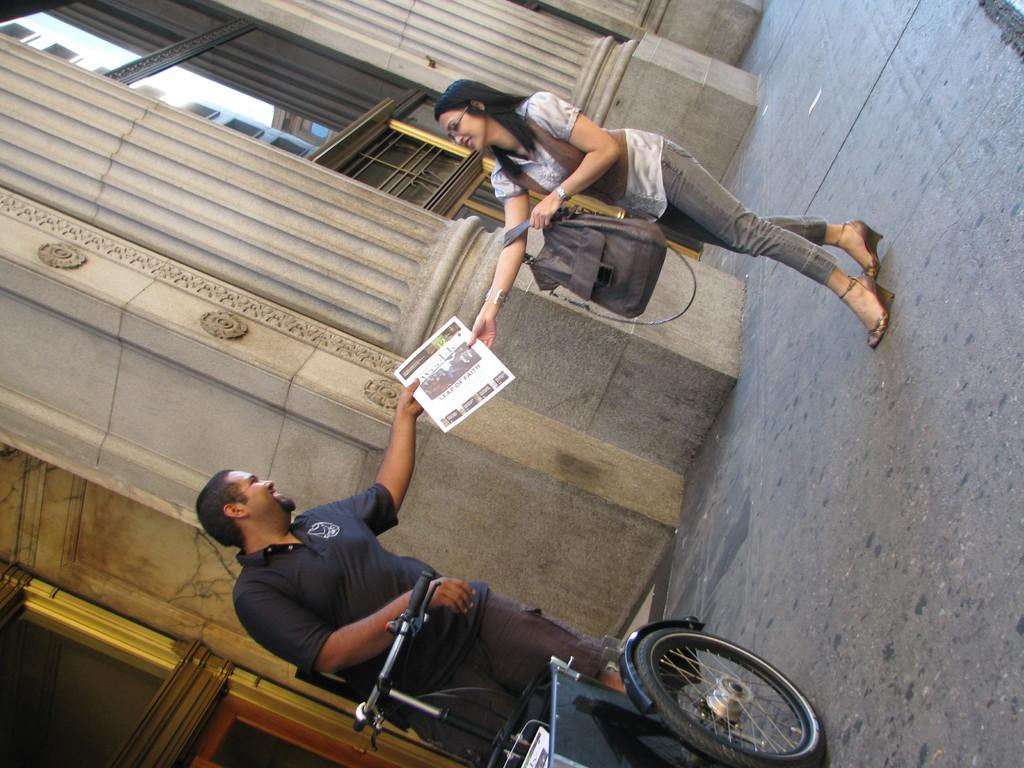Who is present in the image? There is a man and a woman in the image. What are the man and woman doing in the image? Both the man and woman are smiling and holding a paper. What object is in front of the man? There is a tricycle in front of the man. What can be seen in the background of the image? There is a building in the background of the image. What type of poison is the man holding in the image? There is no poison present in the image; the man and woman are holding a paper. What rod-like object can be seen in the image? There is no rod-like object present in the image. 